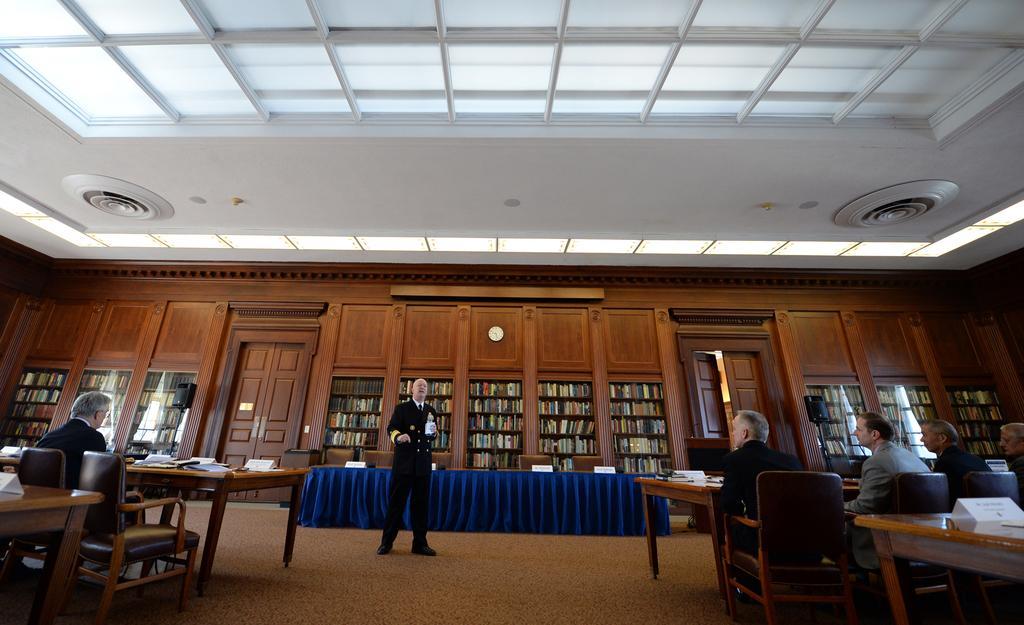Describe this image in one or two sentences. As we can see in the image there is a white color roof, rack and the rack is filled with books. Few people sitting on chairs and there are tables. On tables there are books and the floor is in cream color. 